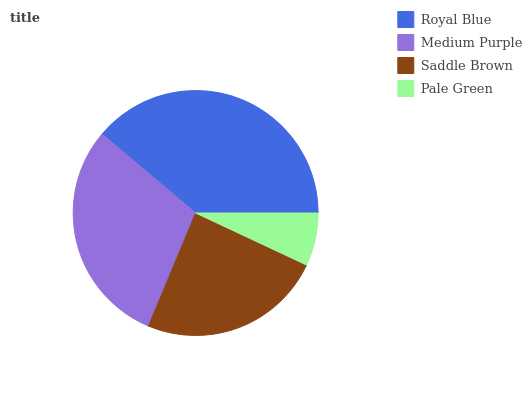Is Pale Green the minimum?
Answer yes or no. Yes. Is Royal Blue the maximum?
Answer yes or no. Yes. Is Medium Purple the minimum?
Answer yes or no. No. Is Medium Purple the maximum?
Answer yes or no. No. Is Royal Blue greater than Medium Purple?
Answer yes or no. Yes. Is Medium Purple less than Royal Blue?
Answer yes or no. Yes. Is Medium Purple greater than Royal Blue?
Answer yes or no. No. Is Royal Blue less than Medium Purple?
Answer yes or no. No. Is Medium Purple the high median?
Answer yes or no. Yes. Is Saddle Brown the low median?
Answer yes or no. Yes. Is Saddle Brown the high median?
Answer yes or no. No. Is Royal Blue the low median?
Answer yes or no. No. 